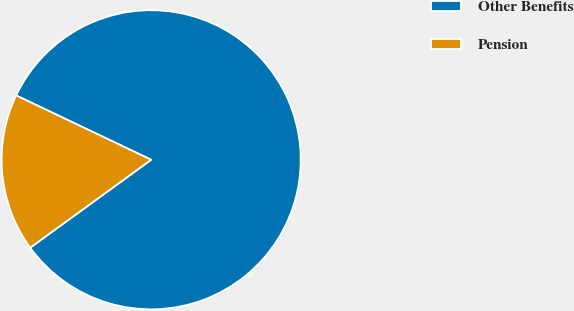Convert chart to OTSL. <chart><loc_0><loc_0><loc_500><loc_500><pie_chart><fcel>Other Benefits<fcel>Pension<nl><fcel>82.92%<fcel>17.08%<nl></chart> 